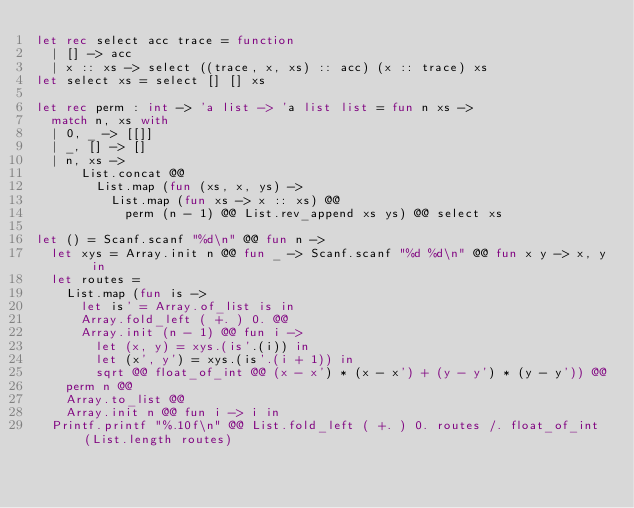<code> <loc_0><loc_0><loc_500><loc_500><_OCaml_>let rec select acc trace = function
  | [] -> acc
  | x :: xs -> select ((trace, x, xs) :: acc) (x :: trace) xs
let select xs = select [] [] xs

let rec perm : int -> 'a list -> 'a list list = fun n xs ->
  match n, xs with
  | 0, _ -> [[]]
  | _, [] -> []
  | n, xs ->
      List.concat @@
        List.map (fun (xs, x, ys) ->
          List.map (fun xs -> x :: xs) @@
            perm (n - 1) @@ List.rev_append xs ys) @@ select xs

let () = Scanf.scanf "%d\n" @@ fun n ->
  let xys = Array.init n @@ fun _ -> Scanf.scanf "%d %d\n" @@ fun x y -> x, y in
  let routes =
    List.map (fun is ->
      let is' = Array.of_list is in
      Array.fold_left ( +. ) 0. @@
      Array.init (n - 1) @@ fun i ->
        let (x, y) = xys.(is'.(i)) in
        let (x', y') = xys.(is'.(i + 1)) in
        sqrt @@ float_of_int @@ (x - x') * (x - x') + (y - y') * (y - y')) @@
    perm n @@
    Array.to_list @@
    Array.init n @@ fun i -> i in
  Printf.printf "%.10f\n" @@ List.fold_left ( +. ) 0. routes /. float_of_int (List.length routes)

</code> 